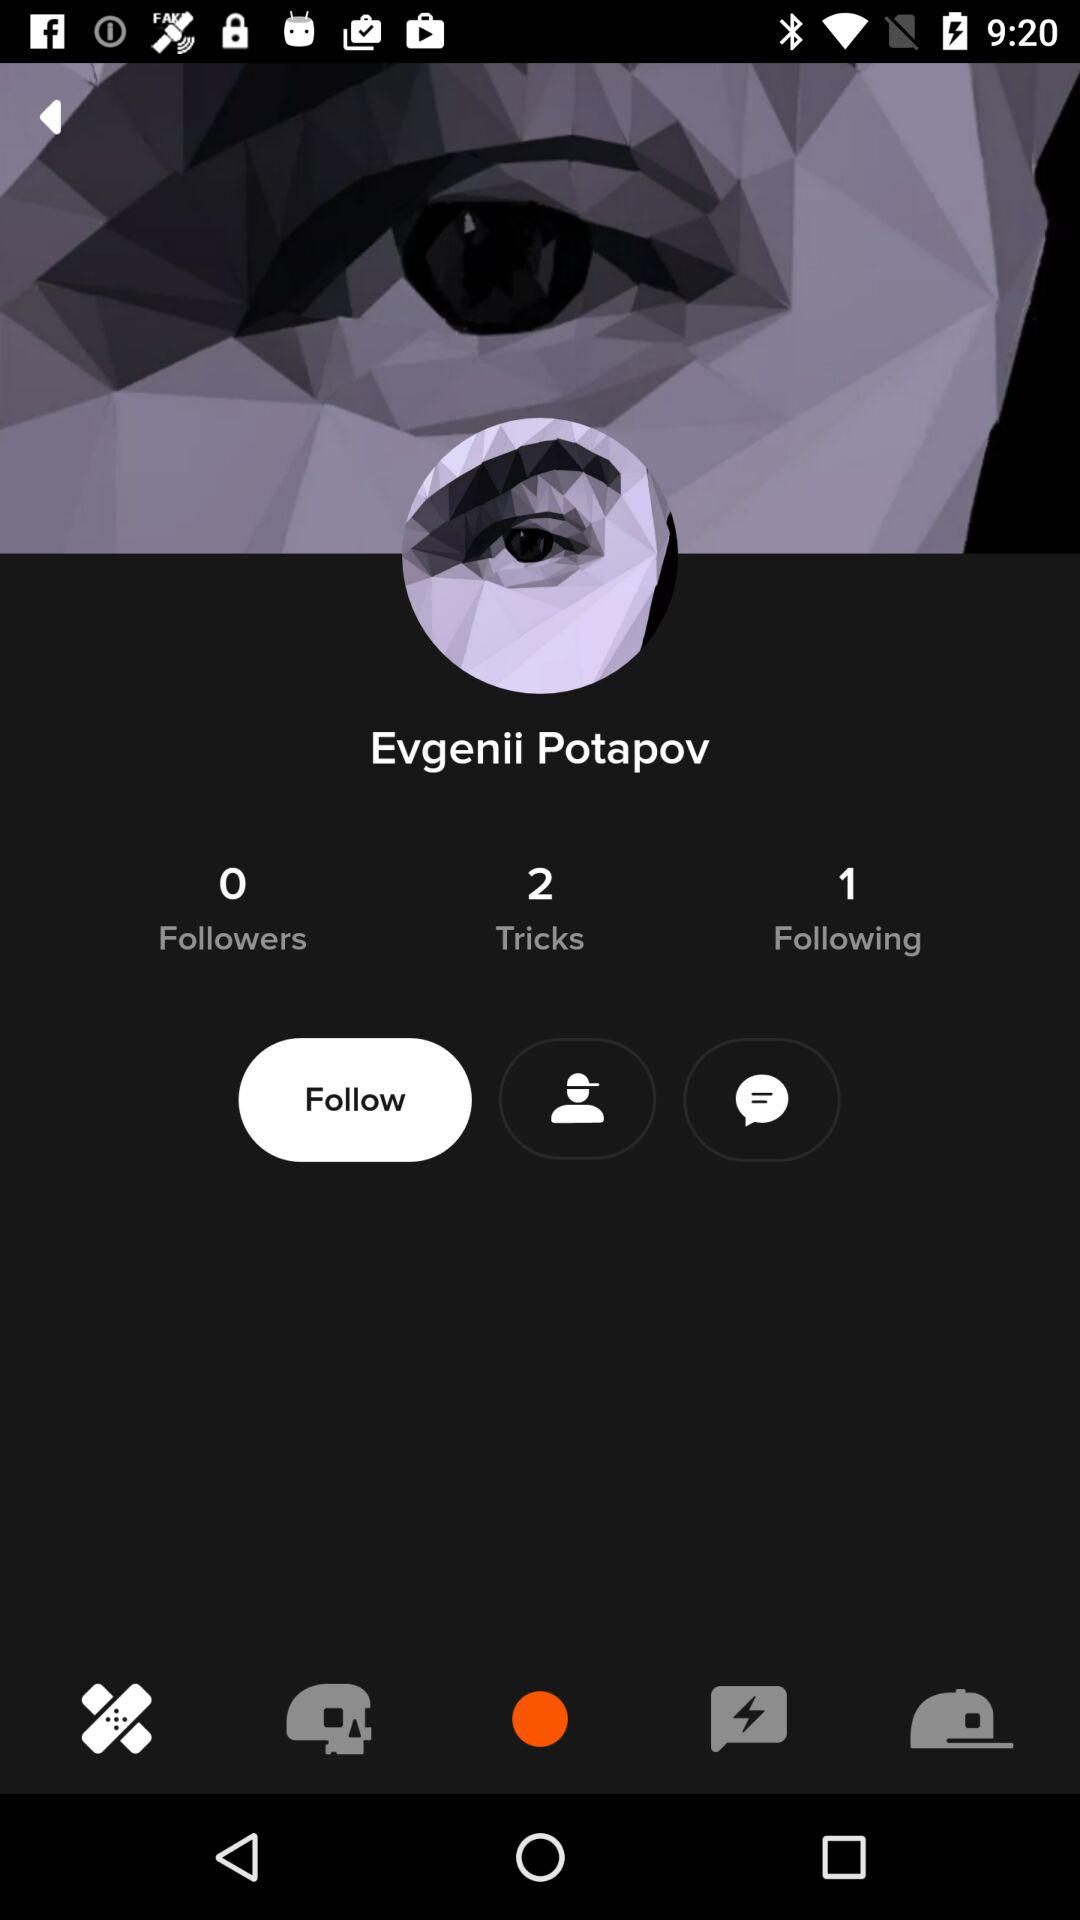What is the name of the user? The name of the user is Evgenii Potapov. 